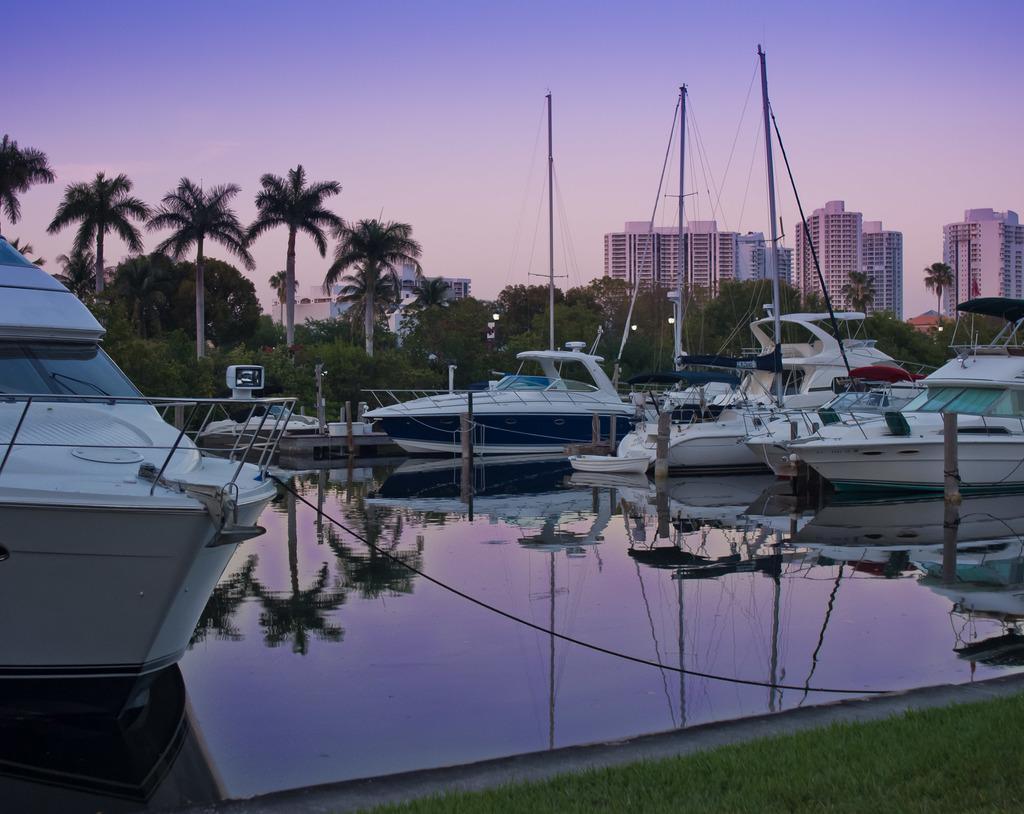Describe this image in one or two sentences. In this image there are boats on a canal, in the background there are trees, buildings and the sky. 